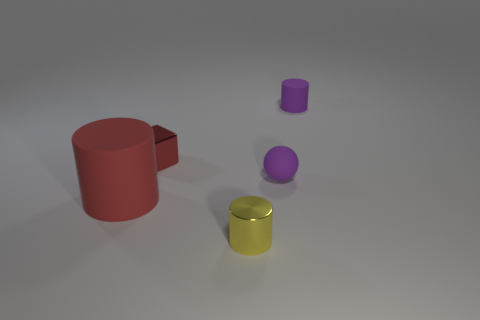What number of things are rubber objects on the left side of the tiny red shiny object or small purple things?
Offer a very short reply. 3. How big is the thing that is to the right of the red cube and behind the purple matte sphere?
Keep it short and to the point. Small. The rubber object that is the same color as the matte ball is what size?
Your answer should be compact. Small. What number of other objects are there of the same size as the metal cube?
Offer a very short reply. 3. What is the color of the cylinder right of the small purple object in front of the rubber cylinder on the right side of the yellow cylinder?
Provide a short and direct response. Purple. There is a thing that is in front of the small ball and behind the small yellow metallic thing; what shape is it?
Offer a very short reply. Cylinder. How many other things are there of the same shape as the big red rubber object?
Offer a very short reply. 2. The purple rubber thing in front of the tiny metallic thing that is left of the cylinder in front of the big object is what shape?
Keep it short and to the point. Sphere. How many things are either red things or small things that are in front of the big red matte object?
Provide a succinct answer. 3. There is a object behind the metallic block; is its shape the same as the object in front of the big red matte cylinder?
Give a very brief answer. Yes. 